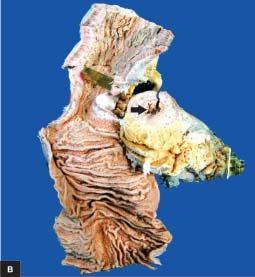does the corresponding area show segment of thickened wall with narrow lumen which is better appreciated in cross section while intervening areas of the bowel are uninvolved or skipped?
Answer the question using a single word or phrase. No 